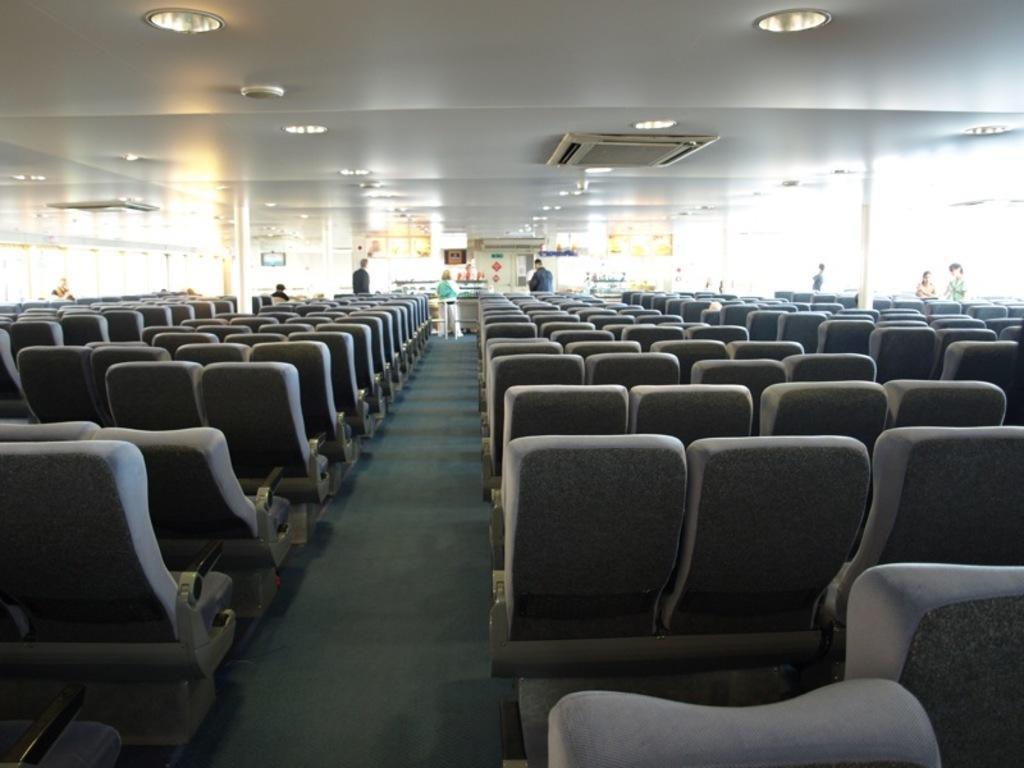In one or two sentences, can you explain what this image depicts? In this image in front there are chairs. There are people. In front of them there are a few objects. On top of the image there are lights. 